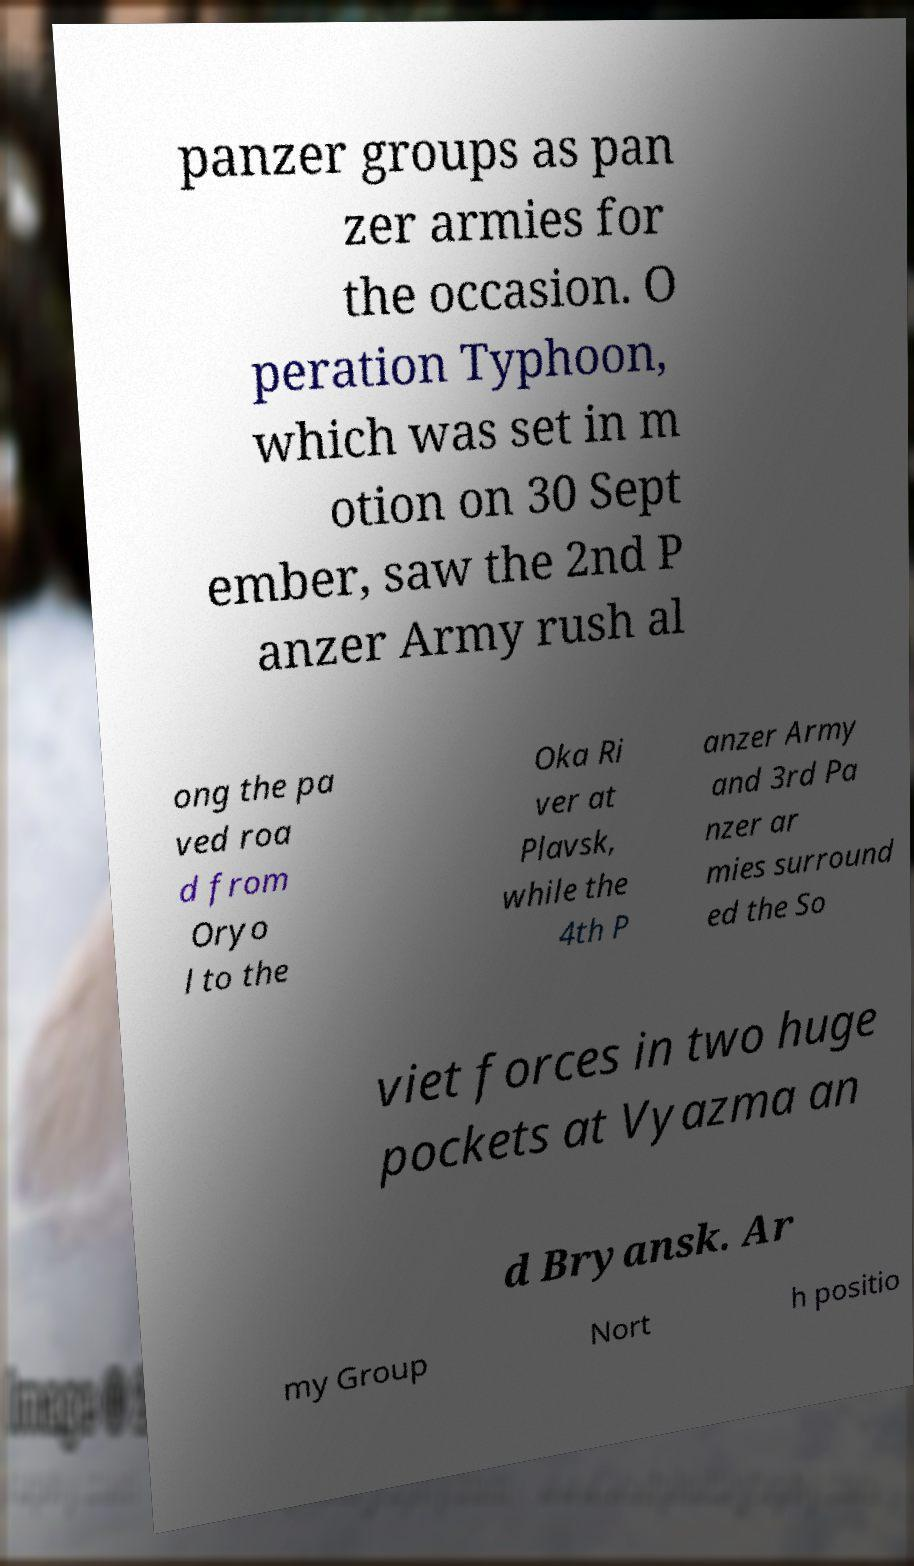Can you accurately transcribe the text from the provided image for me? panzer groups as pan zer armies for the occasion. O peration Typhoon, which was set in m otion on 30 Sept ember, saw the 2nd P anzer Army rush al ong the pa ved roa d from Oryo l to the Oka Ri ver at Plavsk, while the 4th P anzer Army and 3rd Pa nzer ar mies surround ed the So viet forces in two huge pockets at Vyazma an d Bryansk. Ar my Group Nort h positio 